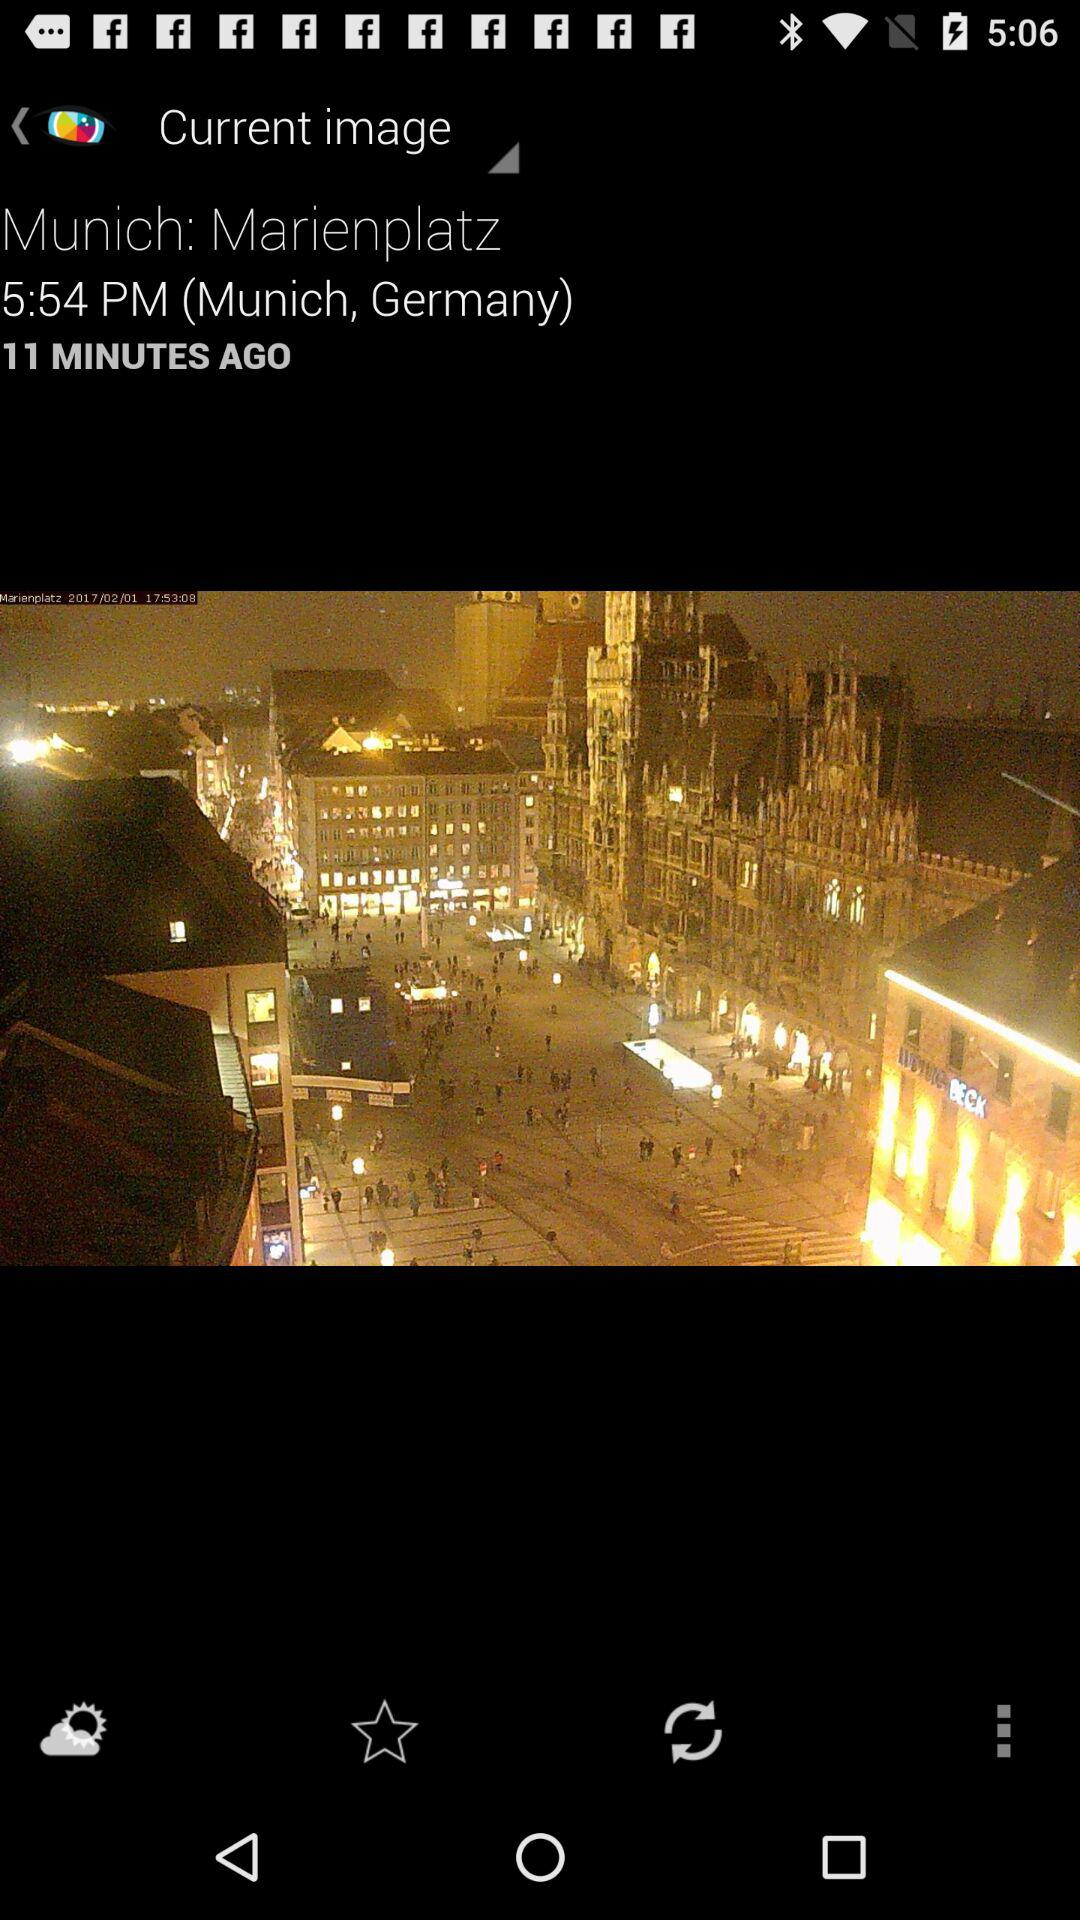What is the time? The time is 5:54 p.m. 